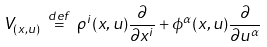<formula> <loc_0><loc_0><loc_500><loc_500>V _ { ( x , u ) } \ { \stackrel { d e f } { = } } \ \rho ^ { i } ( x , u ) { \frac { \partial } { \partial x ^ { i } } } + \phi ^ { \alpha } ( x , u ) { \frac { \partial } { \partial u ^ { \alpha } } }</formula> 